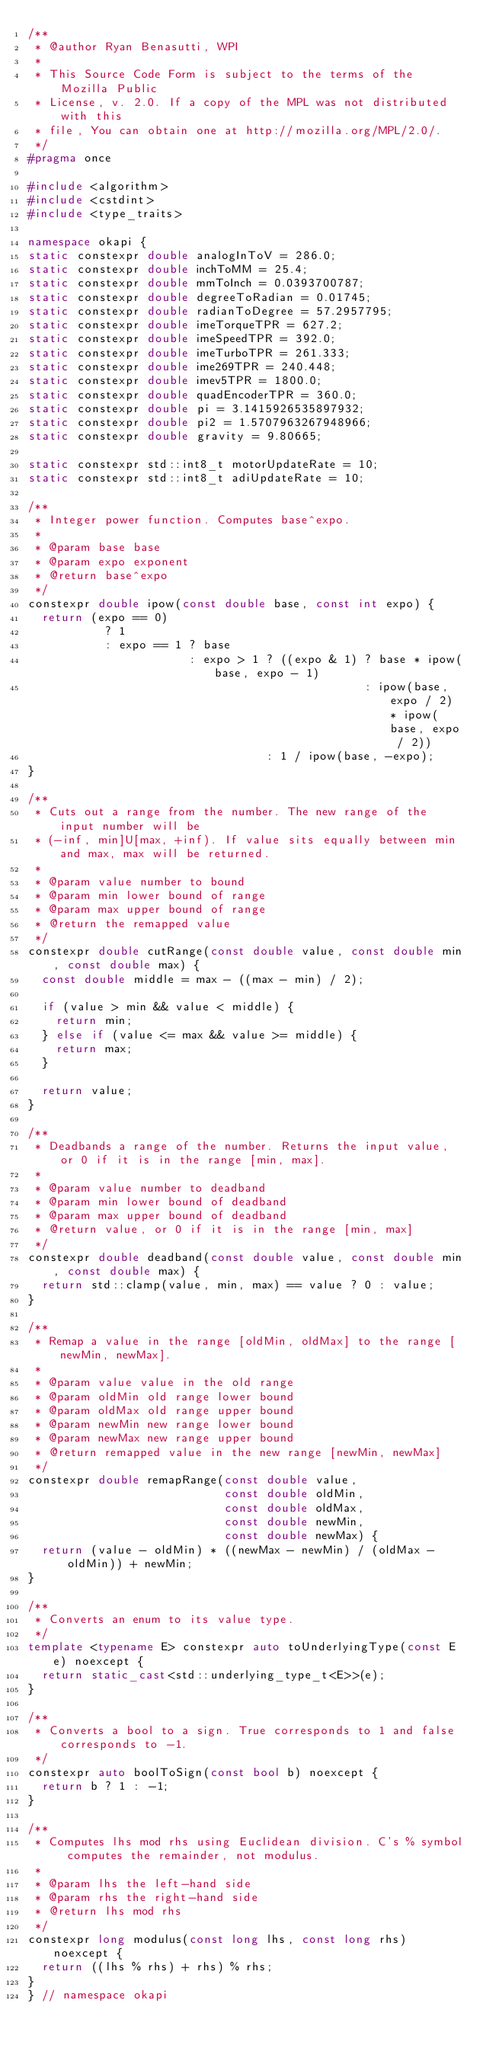Convert code to text. <code><loc_0><loc_0><loc_500><loc_500><_C++_>/**
 * @author Ryan Benasutti, WPI
 *
 * This Source Code Form is subject to the terms of the Mozilla Public
 * License, v. 2.0. If a copy of the MPL was not distributed with this
 * file, You can obtain one at http://mozilla.org/MPL/2.0/.
 */
#pragma once

#include <algorithm>
#include <cstdint>
#include <type_traits>

namespace okapi {
static constexpr double analogInToV = 286.0;
static constexpr double inchToMM = 25.4;
static constexpr double mmToInch = 0.0393700787;
static constexpr double degreeToRadian = 0.01745;
static constexpr double radianToDegree = 57.2957795;
static constexpr double imeTorqueTPR = 627.2;
static constexpr double imeSpeedTPR = 392.0;
static constexpr double imeTurboTPR = 261.333;
static constexpr double ime269TPR = 240.448;
static constexpr double imev5TPR = 1800.0;
static constexpr double quadEncoderTPR = 360.0;
static constexpr double pi = 3.1415926535897932;
static constexpr double pi2 = 1.5707963267948966;
static constexpr double gravity = 9.80665;

static constexpr std::int8_t motorUpdateRate = 10;
static constexpr std::int8_t adiUpdateRate = 10;

/**
 * Integer power function. Computes base^expo.
 *
 * @param base base
 * @param expo exponent
 * @return base^expo
 */
constexpr double ipow(const double base, const int expo) {
  return (expo == 0)
           ? 1
           : expo == 1 ? base
                       : expo > 1 ? ((expo & 1) ? base * ipow(base, expo - 1)
                                                : ipow(base, expo / 2) * ipow(base, expo / 2))
                                  : 1 / ipow(base, -expo);
}

/**
 * Cuts out a range from the number. The new range of the input number will be
 * (-inf, min]U[max, +inf). If value sits equally between min and max, max will be returned.
 *
 * @param value number to bound
 * @param min lower bound of range
 * @param max upper bound of range
 * @return the remapped value
 */
constexpr double cutRange(const double value, const double min, const double max) {
  const double middle = max - ((max - min) / 2);

  if (value > min && value < middle) {
    return min;
  } else if (value <= max && value >= middle) {
    return max;
  }

  return value;
}

/**
 * Deadbands a range of the number. Returns the input value, or 0 if it is in the range [min, max].
 *
 * @param value number to deadband
 * @param min lower bound of deadband
 * @param max upper bound of deadband
 * @return value, or 0 if it is in the range [min, max]
 */
constexpr double deadband(const double value, const double min, const double max) {
  return std::clamp(value, min, max) == value ? 0 : value;
}

/**
 * Remap a value in the range [oldMin, oldMax] to the range [newMin, newMax].
 *
 * @param value value in the old range
 * @param oldMin old range lower bound
 * @param oldMax old range upper bound
 * @param newMin new range lower bound
 * @param newMax new range upper bound
 * @return remapped value in the new range [newMin, newMax]
 */
constexpr double remapRange(const double value,
                            const double oldMin,
                            const double oldMax,
                            const double newMin,
                            const double newMax) {
  return (value - oldMin) * ((newMax - newMin) / (oldMax - oldMin)) + newMin;
}

/**
 * Converts an enum to its value type.
 */
template <typename E> constexpr auto toUnderlyingType(const E e) noexcept {
  return static_cast<std::underlying_type_t<E>>(e);
}

/**
 * Converts a bool to a sign. True corresponds to 1 and false corresponds to -1.
 */
constexpr auto boolToSign(const bool b) noexcept {
  return b ? 1 : -1;
}

/**
 * Computes lhs mod rhs using Euclidean division. C's % symbol computes the remainder, not modulus.
 *
 * @param lhs the left-hand side
 * @param rhs the right-hand side
 * @return lhs mod rhs
 */
constexpr long modulus(const long lhs, const long rhs) noexcept {
  return ((lhs % rhs) + rhs) % rhs;
}
} // namespace okapi
</code> 